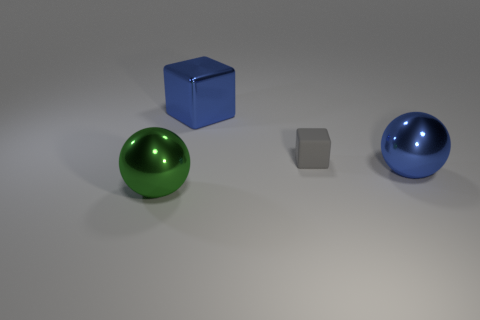Add 2 green balls. How many objects exist? 6 Add 4 small yellow rubber blocks. How many small yellow rubber blocks exist? 4 Subtract 1 gray cubes. How many objects are left? 3 Subtract all large blue metallic objects. Subtract all tiny gray objects. How many objects are left? 1 Add 3 large green balls. How many large green balls are left? 4 